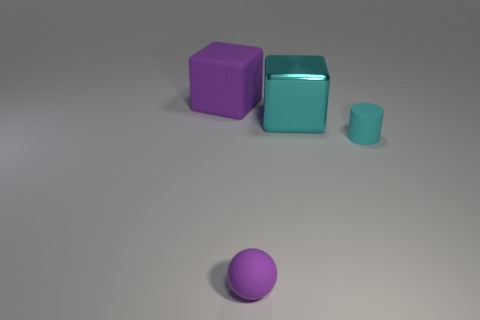Add 3 cyan blocks. How many objects exist? 7 Subtract 1 blocks. How many blocks are left? 1 Subtract all brown blocks. Subtract all cyan balls. How many blocks are left? 2 Subtract all red cylinders. How many cyan cubes are left? 1 Subtract all large purple cubes. Subtract all big cyan things. How many objects are left? 2 Add 3 big purple rubber blocks. How many big purple rubber blocks are left? 4 Add 4 small yellow shiny things. How many small yellow shiny things exist? 4 Subtract 0 green blocks. How many objects are left? 4 Subtract all cylinders. How many objects are left? 3 